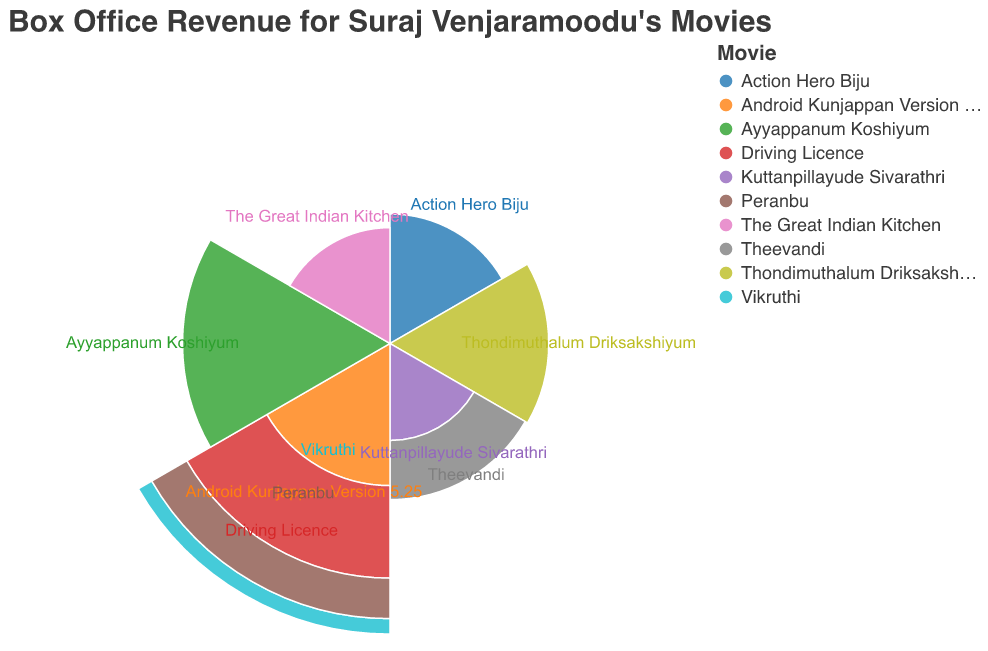What is the title of the polar chart? The title of the chart is prominently displayed at the top, which reflects the main focus of the visualization.
Answer: Box Office Revenue for Suraj Venjaramoodu's Movies In which year did Suraj Venjaramoodu's movies achieve the highest box office revenue? The length of the radius in a polar chart indicates the value, so the longest radius represents the highest revenue.
Answer: 2020 What is the box office revenue for "Driving Licence"? The chart uses color to represent different movies, and each movie's box office revenue is shown as the radius length corresponding to its year.
Answer: 42.6 INR Crores Which movie released in 2019 had the lowest box office revenue? By examining the arcs corresponding to the year 2019, we can compare their lengths. The shortest arc represents the movie with the lowest revenue.
Answer: Vikruthi What is the total box office revenue for all movies released in 2019? To find this, sum the revenues of all the movies released in 2019 by checking their respective data points: Android Kunjappan Version 5.25, Driving Licence, Vikruthi, and Peranbu.
Answer: 103.2 INR Crores Which year had the most movies featuring Suraj Venjaramoodu? The chart can show multiple arcs for a single year, representing different movies. The year with the most arcs is the answer.
Answer: 2019 Among the movies released in 2018, which one had a higher box office revenue? By comparing the arcs for the movies released in 2018 ("Kuttanpillayude Sivarathri" and "Theevandi"), the one with a longer radius represents the higher revenue.
Answer: Theevandi How does the box office revenue of "Ayyappanum Koshiyum" compare to "Thondimuthalum Driksakshiyum"? Compare the length of the radii for these two movies. Since "Ayyappanum Koshiyum" has a longer radius, it indicates higher revenue.
Answer: Ayyappanum Koshiyum has higher revenue What is the average box office revenue of Suraj Venjaramoodu's movies released in 2018? Calculate the average by summing the revenues of the movies released in 2018 and then dividing by the number of movies. (11.5 + 18.3) / 2
Answer: 14.9 INR Crores Which movie released after 2019 had the highest box office revenue? Compare the arcs for the movies released after 2019 ("Ayyappanum Koshiyum" and "The Great Indian Kitchen"); the one with the longest radius represents the highest revenue.
Answer: Ayyappanum Koshiyum 